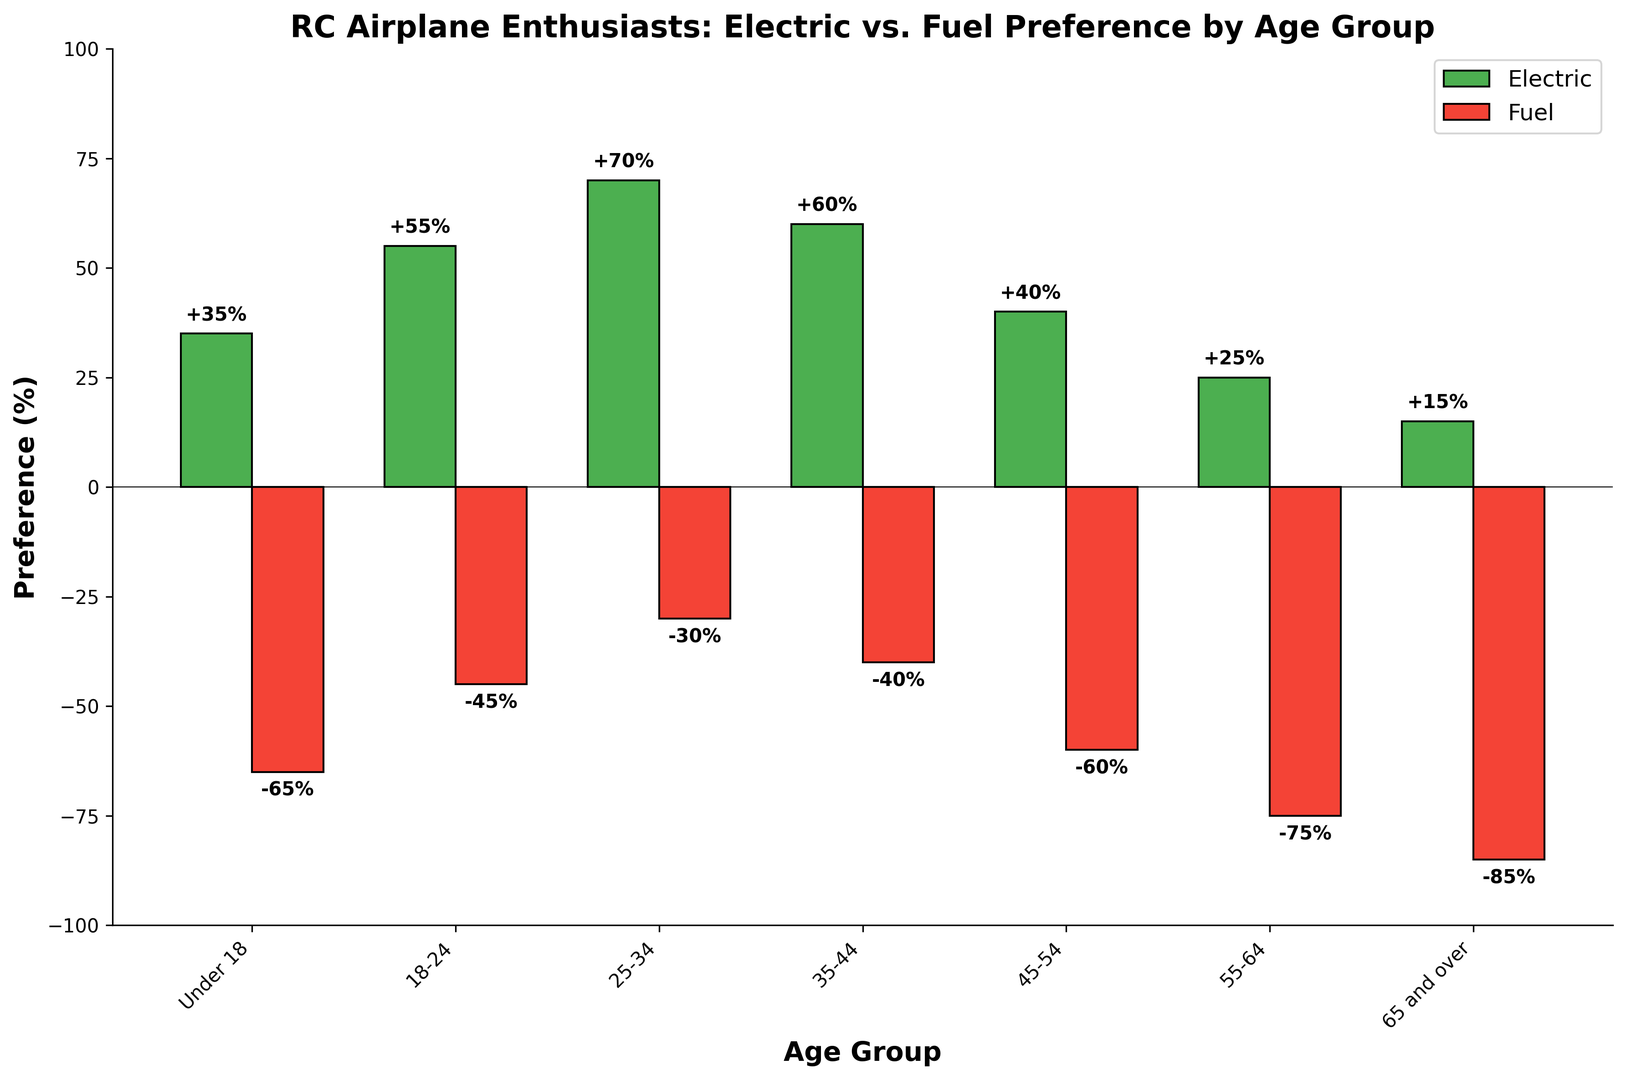Which age group has the highest preference for electric models? The '25-34' age group has the highest percentage for electric preference, as shown by the tallest green bar.
Answer: 25-34 Which age group has the most significant preference for fuel models? The '65 and over' age group has the most negative value for fuel preference, indicated by the deepest red bar.
Answer: 65 and over What is the difference in electric preference between the '18-24' and the '55-64' age groups? The '18-24' age group prefers electric models by 55%, while the '55-64' age group prefers them by 25%. The difference is 55% - 25% = 30%.
Answer: 30% Which age group shows an equal preference for electric and fuel models? The 'Electric Preference (%)' and 'Fuel Preference (%)' values for each age group are different. None of the age groups have equal preferences for both.
Answer: None How does the preference for fuel models change as age increases? As age increases, preference for fuel models consistently becomes more negative. This can be observed through the downward trend of the red bars from younger to older age groups.
Answer: Decreases What is the combined preference percentage for electric models for the 'Under 18' and '25-34' age groups? The 'Under 18' group has a 35% preference, and the '25-34' group has a 70% preference. Combined: 35% + 70% = 105%.
Answer: 105% Which age group has the closest preference values between electric and fuel models? The '45-54' group shows a smaller gap between preferences (40% for electric and -60% for fuel, a 100% absolute difference) compared to other groups with larger gaps.
Answer: 45-54 What's the trend in electric preference from 'Under 18' to '65 and over'? Electric preference first increases, peaks at the '25-34' group, and then decreases. This trend is visible by observing the height of the green bars.
Answer: Peaks then decreases If we average the fuel preference values for all age groups, what is the result? Summing the percentages: -65, -45, -30, -40, -60, -75, -85 gives -400. Dividing by 7 age groups, the average is -400/7 ≈ -57.14%.
Answer: -57.14% Which age group has the smallest absolute preference for electric models? The '65 and over' group shows the smallest absolute preference with a 15% preference for electric models, as seen by the shortest green bar.
Answer: 65 and over 